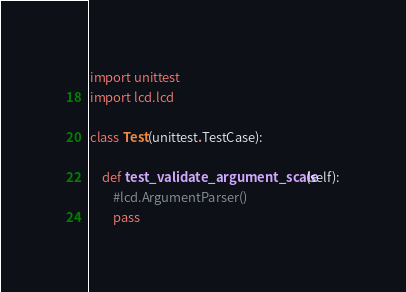Convert code to text. <code><loc_0><loc_0><loc_500><loc_500><_Python_>import unittest
import lcd.lcd

class Test(unittest.TestCase):

    def test_validate_argument_scale(self):
        #lcd.ArgumentParser()
        pass

</code> 